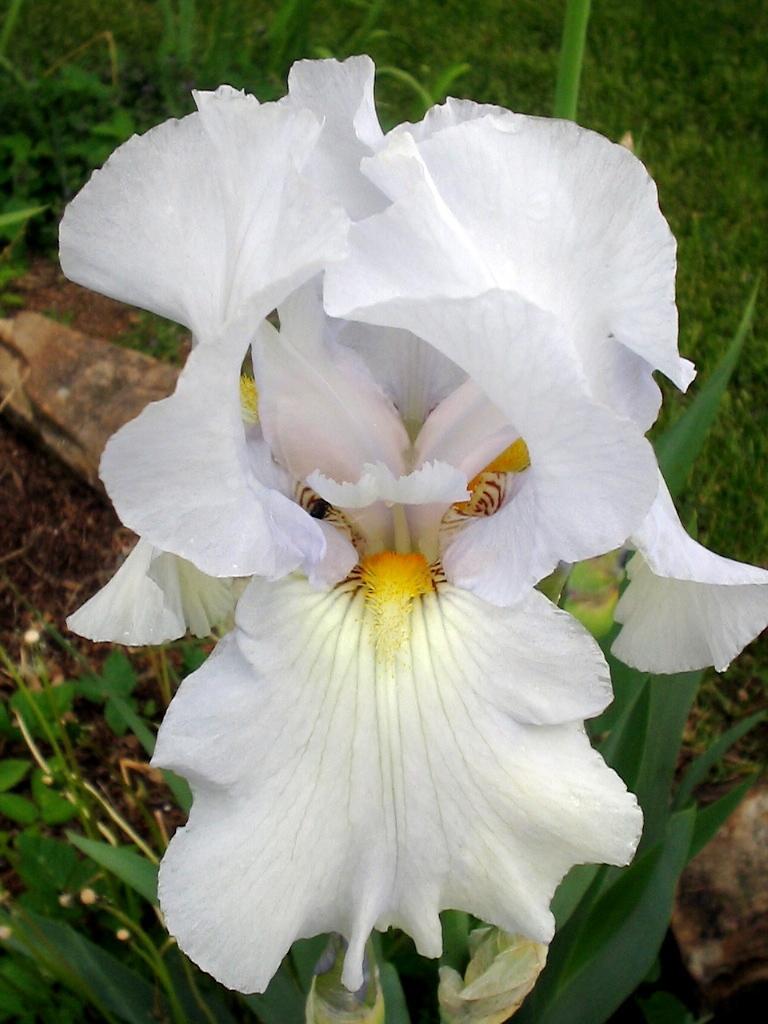In one or two sentences, can you explain what this image depicts? In this image I can see few flowers in white and yellow color, background I can see few plants in green color. 